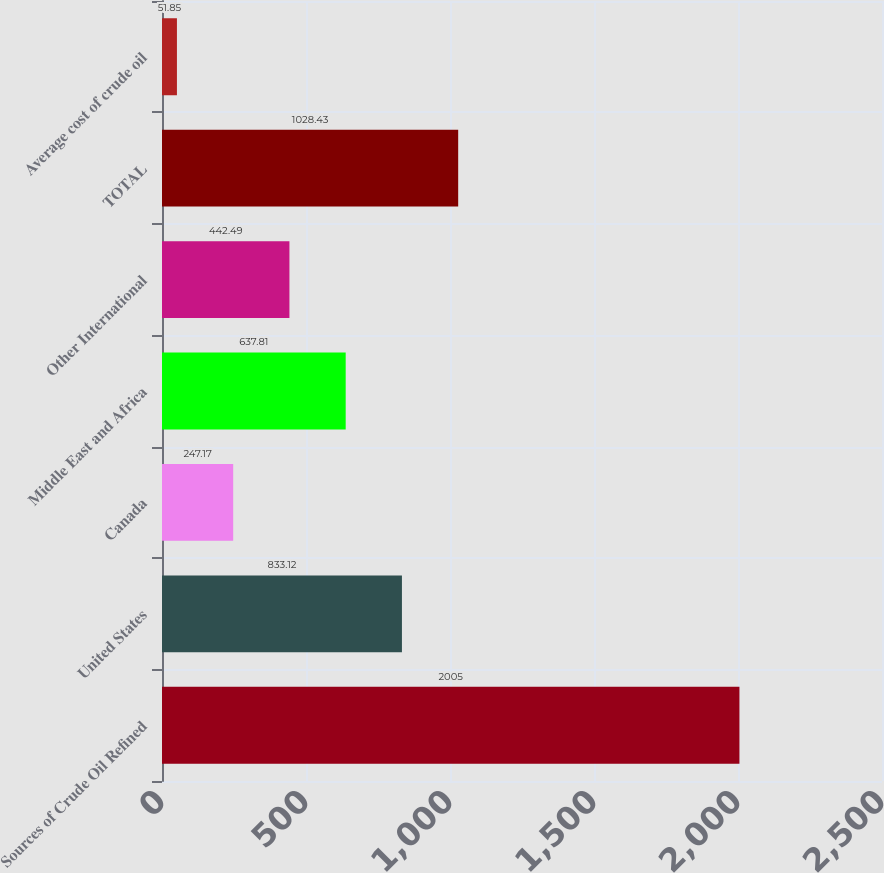<chart> <loc_0><loc_0><loc_500><loc_500><bar_chart><fcel>Sources of Crude Oil Refined<fcel>United States<fcel>Canada<fcel>Middle East and Africa<fcel>Other International<fcel>TOTAL<fcel>Average cost of crude oil<nl><fcel>2005<fcel>833.12<fcel>247.17<fcel>637.81<fcel>442.49<fcel>1028.43<fcel>51.85<nl></chart> 